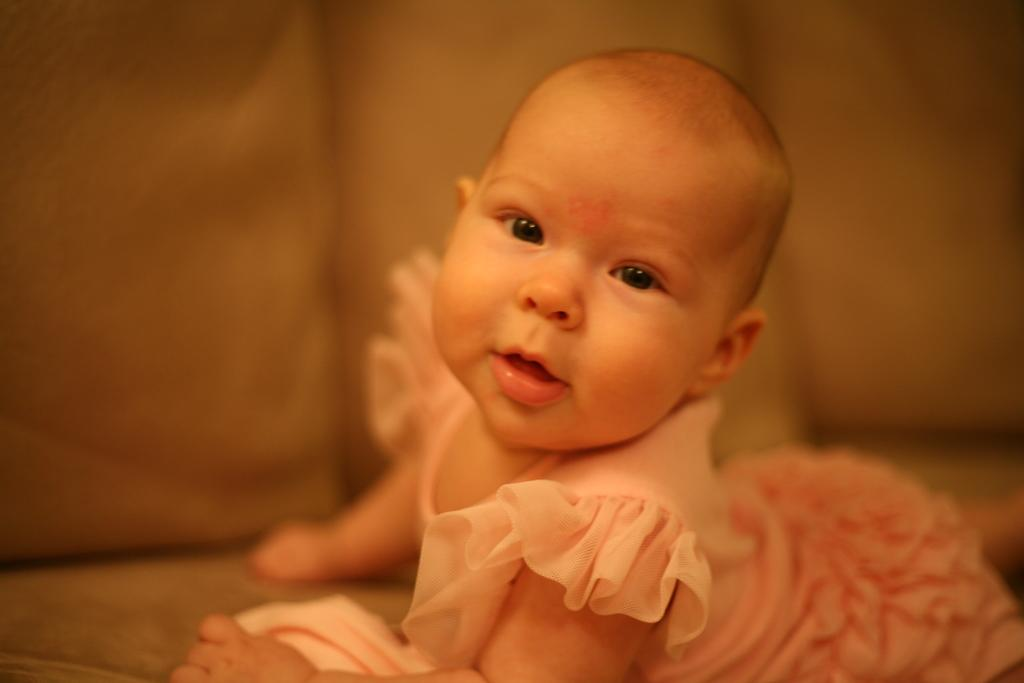What is the main subject of the image? There is a baby in the image. Can you describe the background of the image? The background of the image is blurry. How many bikes are being ridden by the baby in the image? There are no bikes present in the image; it features a baby. What type of apples is the baby holding in the image? There are no apples present in the image; it features a baby. 